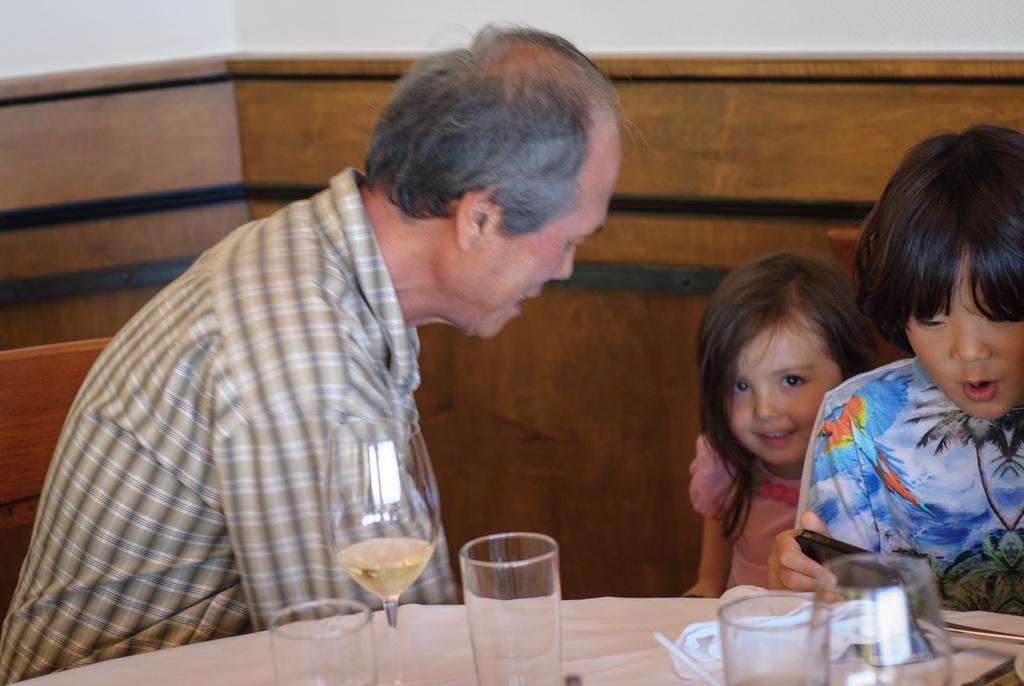Who is present in the image? There is an old man and two kids in the image. What are they doing in the image? The old man and kids are sitting in front of front of a table. What objects can be seen on the table? There are glasses, plates, and cups on the table. What is behind the table? There is a wall behind the table. What type of pear is being discussed by the committee in the image? There is no pear or committee present in the image. Are the police involved in the situation depicted in the image? There is no indication of police involvement in the image. 